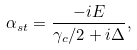Convert formula to latex. <formula><loc_0><loc_0><loc_500><loc_500>\alpha _ { s t } = \frac { - i E } { \gamma _ { c } / 2 + i \Delta } ,</formula> 